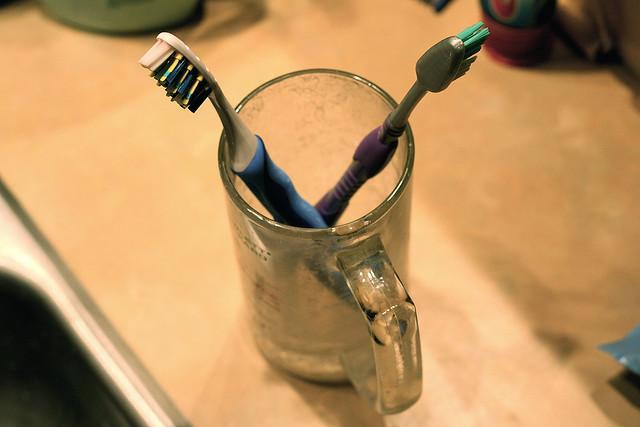How many people use this bathroom? two 